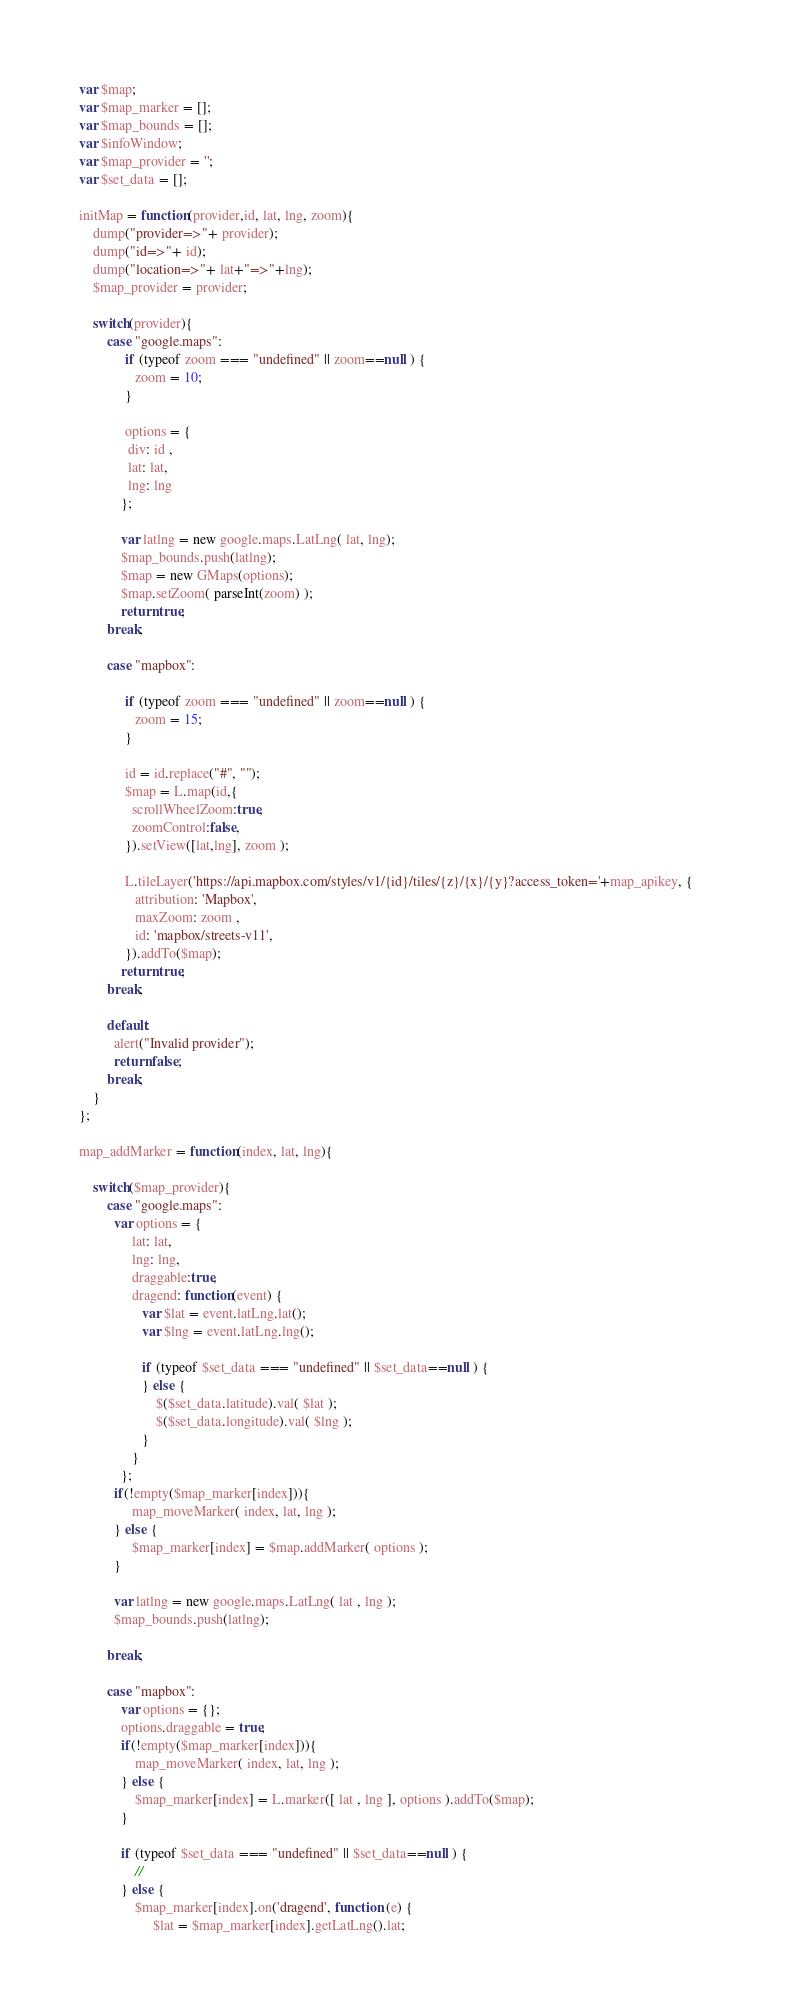<code> <loc_0><loc_0><loc_500><loc_500><_JavaScript_>var $map;
var $map_marker = [];
var $map_bounds = [];
var $infoWindow;
var $map_provider = '';
var $set_data = [];

initMap = function(provider,id, lat, lng, zoom){
	dump("provider=>"+ provider);
	dump("id=>"+ id);
	dump("location=>"+ lat+"=>"+lng);
	$map_provider = provider;
	
	switch(provider){			
		case "google.maps":				
			 if (typeof zoom === "undefined" || zoom==null ) {
				zoom = 10;
			 }				 
			 		
			 options = {
			  div: id ,
			  lat: lat,
			  lng: lng		  
			};
			
			var latlng = new google.maps.LatLng( lat, lng);
		    $map_bounds.push(latlng);
		    $map = new GMaps(options);	
		    $map.setZoom( parseInt(zoom) );
		    return true;
		break;
		
		case "mapbox":
		
			 if (typeof zoom === "undefined" || zoom==null ) {
				zoom = 15;
			 }		
			 
			 id = id.replace("#", "");			    			   
			 $map = L.map(id,{ 
			   scrollWheelZoom:true,
			   zoomControl:false,
		     }).setView([lat,lng], zoom );  
		    
		     L.tileLayer('https://api.mapbox.com/styles/v1/{id}/tiles/{z}/{x}/{y}?access_token='+map_apikey, {	
		    	attribution: 'Mapbox',
			    maxZoom: zoom ,
			    id: 'mapbox/streets-v11',		    
			 }).addTo($map);
			return true;
		break;
		
		default:
		  alert("Invalid provider");
		  return false;
		break;
	}
};

map_addMarker = function(index, lat, lng){
		
	switch($map_provider){
		case "google.maps":	
		  var options = {
		       lat: lat,
			   lng: lng,
			   draggable:true,
			   dragend: function(event) {
			   	  var $lat = event.latLng.lat();
                  var $lng = event.latLng.lng();
                  
                  if (typeof $set_data === "undefined" || $set_data==null ) {
                  } else {
	                  $($set_data.latitude).val( $lat );
	                  $($set_data.longitude).val( $lng );
                  }
			   }
		    };
		  if(!empty($map_marker[index])){
		  	   map_moveMarker( index, lat, lng );
		  } else {
		  	   $map_marker[index] = $map.addMarker( options );
		  }
		  
		  var latlng = new google.maps.LatLng( lat , lng );
	      $map_bounds.push(latlng);		  
		  
		break;
		
		case "mapbox":
			var options = {};
			options.draggable = true;
			if(!empty($map_marker[index])){
				map_moveMarker( index, lat, lng );
			} else {
				$map_marker[index] = L.marker([ lat , lng ], options ).addTo($map);  
			}
			
			if (typeof $set_data === "undefined" || $set_data==null ) {
				//
			} else {
				$map_marker[index].on('dragend', function (e) {
					 $lat = $map_marker[index].getLatLng().lat;</code> 